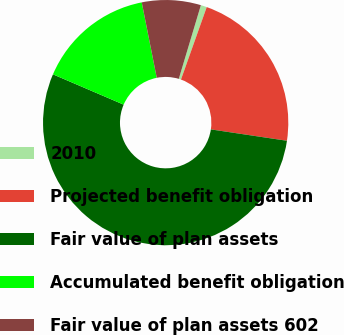Convert chart. <chart><loc_0><loc_0><loc_500><loc_500><pie_chart><fcel>2010<fcel>Projected benefit obligation<fcel>Fair value of plan assets<fcel>Accumulated benefit obligation<fcel>Fair value of plan assets 602<nl><fcel>0.8%<fcel>21.93%<fcel>54.08%<fcel>15.43%<fcel>7.76%<nl></chart> 